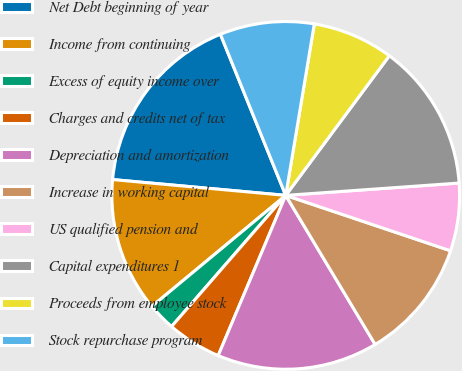<chart> <loc_0><loc_0><loc_500><loc_500><pie_chart><fcel>Net Debt beginning of year<fcel>Income from continuing<fcel>Excess of equity income over<fcel>Charges and credits net of tax<fcel>Depreciation and amortization<fcel>Increase in working capital<fcel>US qualified pension and<fcel>Capital expenditures 1<fcel>Proceeds from employee stock<fcel>Stock repurchase program<nl><fcel>17.42%<fcel>12.47%<fcel>2.58%<fcel>5.05%<fcel>14.95%<fcel>11.24%<fcel>6.29%<fcel>13.71%<fcel>7.53%<fcel>8.76%<nl></chart> 